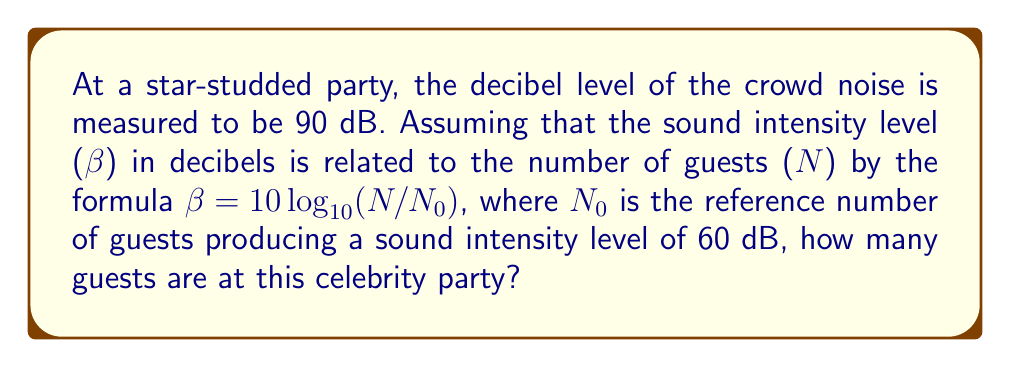Help me with this question. Let's approach this step-by-step:

1) We are given the formula: β = 10 log₁₀(N/N₀)
   Where β is the sound intensity level in decibels, N is the number of guests, and N₀ is the reference number of guests.

2) We know that β = 90 dB for this party.

3) We also know that N₀ corresponds to 60 dB. Let's find N₀:
   60 = 10 log₁₀(N₀/N₀)
   60 = 10 log₁₀(1)
   60 = 0
   This equation is true, so our reference point is correct.

4) Now, let's plug in our known values:
   90 = 10 log₁₀(N/N₀)

5) Divide both sides by 10:
   9 = log₁₀(N/N₀)

6) Apply 10^ to both sides:
   10⁹ = N/N₀

7) Multiply both sides by N₀:
   N = N₀ * 10⁹

8) We know N₀ corresponds to 60 dB, which is 10⁶ guests (from the logarithmic scale).

9) Therefore:
   N = 10⁶ * 10⁹ = 10¹⁵

Thus, there are 10¹⁵ guests at the party.
Answer: $10^{15}$ guests 